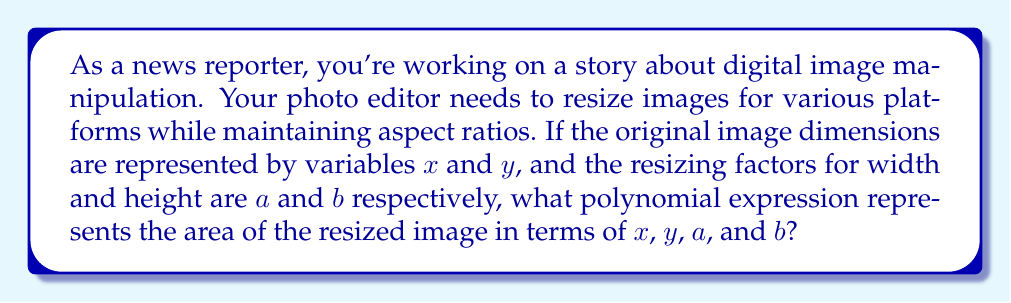Could you help me with this problem? Let's approach this step-by-step:

1) The original image dimensions are $x$ (width) and $y$ (height).

2) The original area of the image is $A = xy$.

3) The resizing factors are:
   - $a$ for width
   - $b$ for height

4) After resizing:
   - New width = $ax$
   - New height = $by$

5) The area of the resized image is:
   $A_{new} = (ax)(by)$

6) Expanding this expression:
   $A_{new} = abxy$

7) This is a polynomial expression where:
   - $ab$ is the coefficient
   - $x$ and $y$ are the variables
   - The degree of the polynomial is 2 (1 for $x$ and 1 for $y$)

Therefore, the polynomial representing the area of the resized image is $abxy$.
Answer: $abxy$ 